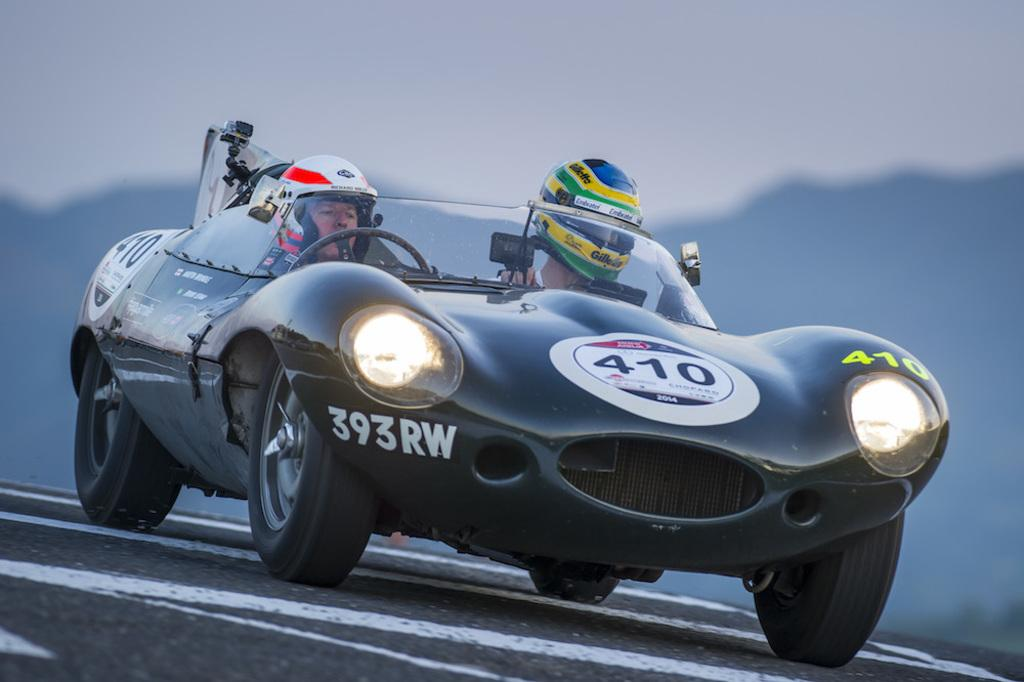What type of vehicle is in the image? There is a sports car in the image. Where is the sports car located? The sports car is on the road. How many people are inside the sports car? There are two persons sitting in the car. What are the persons wearing while in the car? The persons are wearing helmets. What type of guitar can be seen being played by the group in the image? There is no guitar or group present in the image; it features a sports car with two persons wearing helmets. 